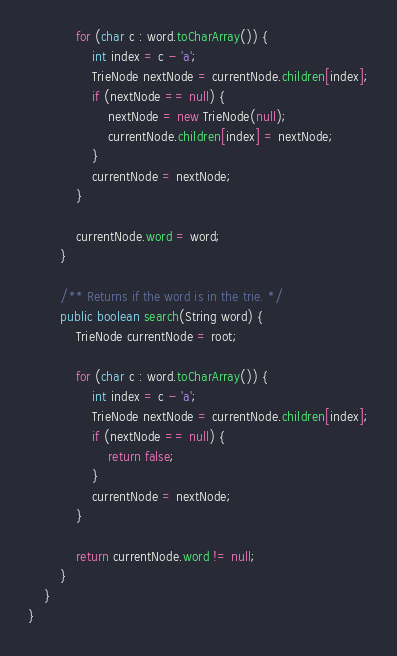Convert code to text. <code><loc_0><loc_0><loc_500><loc_500><_Java_>
            for (char c : word.toCharArray()) {
                int index = c - 'a';
                TrieNode nextNode = currentNode.children[index];
                if (nextNode == null) {
                    nextNode = new TrieNode(null);
                    currentNode.children[index] = nextNode;
                }
                currentNode = nextNode;
            }

            currentNode.word = word;
        }

        /** Returns if the word is in the trie. */
        public boolean search(String word) {
            TrieNode currentNode = root;

            for (char c : word.toCharArray()) {
                int index = c - 'a';
                TrieNode nextNode = currentNode.children[index];
                if (nextNode == null) {
                    return false;
                }
                currentNode = nextNode;
            }

            return currentNode.word != null;
        }
    }
}
</code> 